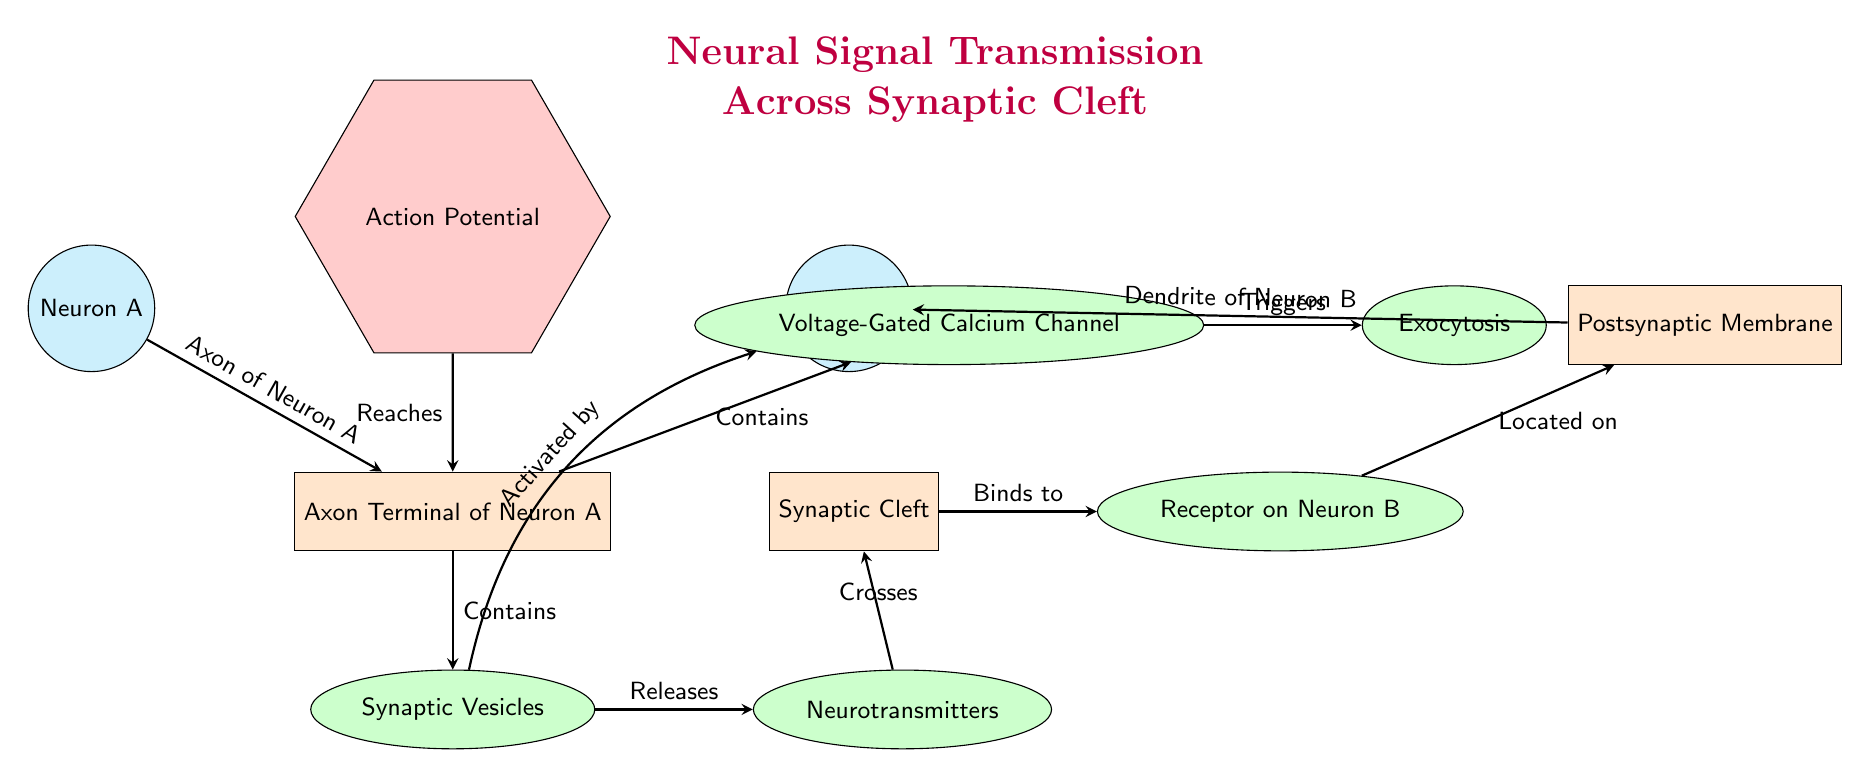What are the two neurons depicted in the diagram? The diagram shows Neuron A and Neuron B as the two neurons involved in the synaptic transmission process. They are clearly labeled on opposite sides of the diagram.
Answer: Neuron A, Neuron B What is the role of synaptic vesicles? Synaptic vesicles are shown in the diagram to contain neurotransmitters that are released into the synaptic cleft during transmission. The labels indicate their location and function.
Answer: Contains neurotransmitters What triggers exocytosis in the axon terminal of Neuron A? The diagram indicates that the activation of the voltage-gated calcium channels is what triggers exocytosis, where neurotransmitters are released. This step is indicated by arrows showing the flow of events.
Answer: Voltage-Gated Calcium Channel How does neurotransmitter reach Neuron B? According to the diagram, neurotransmitters are released from synaptic vesicles, cross the synaptic cleft, and then bind to the receptors on Neuron B. This is a sequence of events illustrated by arrows showing the flow of neurotransmitter movement.
Answer: Crosses synaptic cleft What is the sequence of events that lead to the release of neurotransmitters? The sequence begins with action potentials reaching the axon terminal of Neuron A. This leads to the activation of voltage-gated calcium channels, triggering exocytosis and the release of neurotransmitters. Connecting these events shows how they depend on each other.
Answer: Action potential → Voltage-Gated Calcium Channel → Exocytosis How is the postsynaptic membrane related to Neuron B? The diagram shows that the postsynaptic membrane is located on Neuron B and has receptors that bind to neurotransmitters. This illustrates the direct connection between the postsynaptic membrane and its neuron.
Answer: Located on Neuron B How is the action potential initiated in Neuron A? As shown in the diagram, an action potential is shown to reach the axon terminal of Neuron A, indicating that it initiates the entire process of neural signal transmission. This is shown as a precursor event that starts the transmission process.
Answer: Reaches axon terminal of Neuron A What components are found in the synaptic cleft? The diagram specifies that the synaptic cleft contains no specific components other than being a gap where neurotransmitters cross. This indicates its role as a space for interaction between the neuron's signals.
Answer: Synaptic Cleft What is the function of receptors on Neuron B? The receptors on Neuron B are designated to bind with neurotransmitters as they transmit signals across the synaptic cleft. This role is critical for the continuation of the signal transmission process illustrated.
Answer: Binds to neurotransmitters 